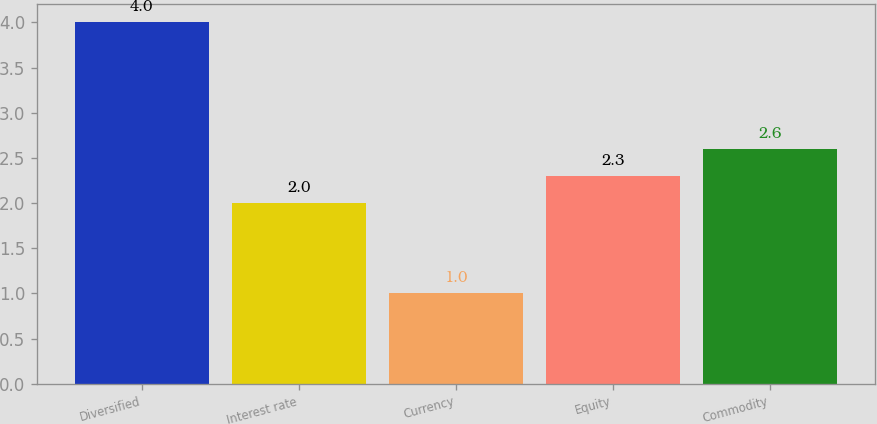<chart> <loc_0><loc_0><loc_500><loc_500><bar_chart><fcel>Diversified<fcel>Interest rate<fcel>Currency<fcel>Equity<fcel>Commodity<nl><fcel>4<fcel>2<fcel>1<fcel>2.3<fcel>2.6<nl></chart> 